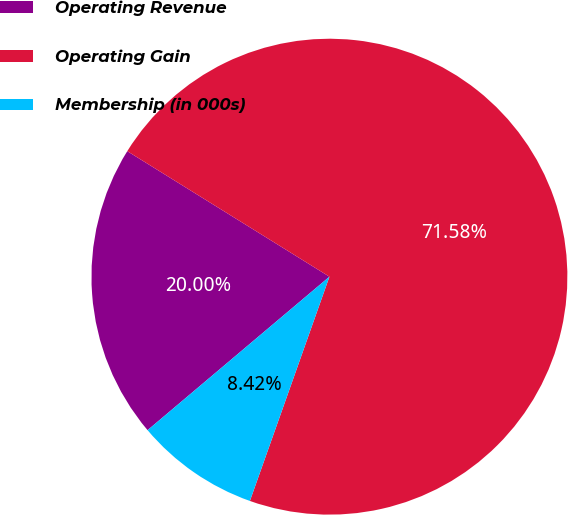<chart> <loc_0><loc_0><loc_500><loc_500><pie_chart><fcel>Operating Revenue<fcel>Operating Gain<fcel>Membership (in 000s)<nl><fcel>20.0%<fcel>71.58%<fcel>8.42%<nl></chart> 